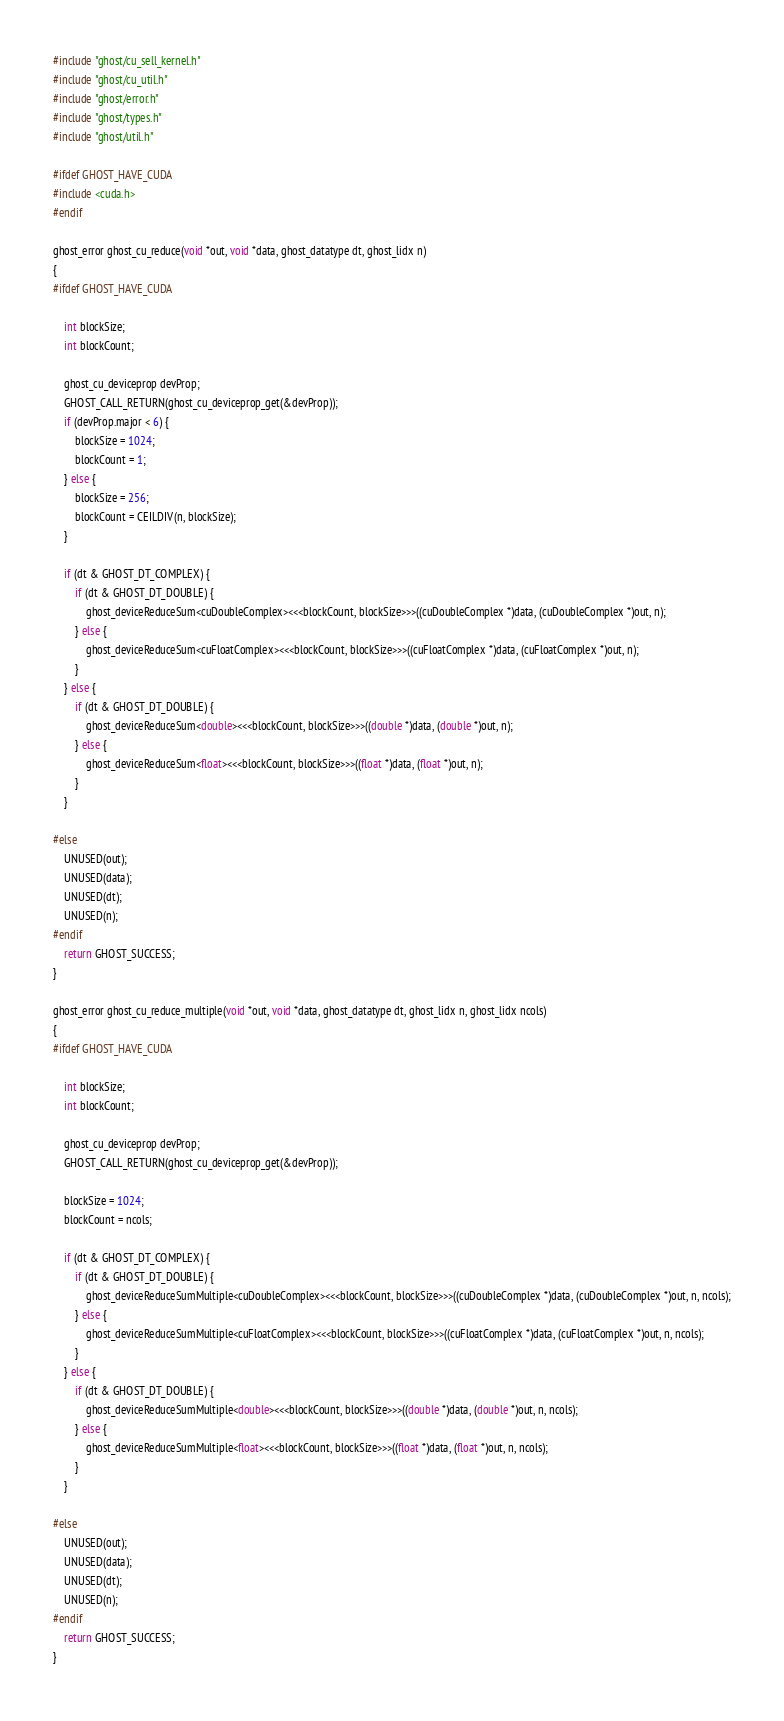Convert code to text. <code><loc_0><loc_0><loc_500><loc_500><_Cuda_>#include "ghost/cu_sell_kernel.h"
#include "ghost/cu_util.h"
#include "ghost/error.h"
#include "ghost/types.h"
#include "ghost/util.h"

#ifdef GHOST_HAVE_CUDA
#include <cuda.h>
#endif

ghost_error ghost_cu_reduce(void *out, void *data, ghost_datatype dt, ghost_lidx n)
{
#ifdef GHOST_HAVE_CUDA

    int blockSize;
    int blockCount;

    ghost_cu_deviceprop devProp;
    GHOST_CALL_RETURN(ghost_cu_deviceprop_get(&devProp));
    if (devProp.major < 6) {
        blockSize = 1024;
        blockCount = 1;
    } else {
        blockSize = 256;
        blockCount = CEILDIV(n, blockSize);
    }

    if (dt & GHOST_DT_COMPLEX) {
        if (dt & GHOST_DT_DOUBLE) {
            ghost_deviceReduceSum<cuDoubleComplex><<<blockCount, blockSize>>>((cuDoubleComplex *)data, (cuDoubleComplex *)out, n);
        } else {
            ghost_deviceReduceSum<cuFloatComplex><<<blockCount, blockSize>>>((cuFloatComplex *)data, (cuFloatComplex *)out, n);
        }
    } else {
        if (dt & GHOST_DT_DOUBLE) {
            ghost_deviceReduceSum<double><<<blockCount, blockSize>>>((double *)data, (double *)out, n);
        } else {
            ghost_deviceReduceSum<float><<<blockCount, blockSize>>>((float *)data, (float *)out, n);
        }
    }

#else
    UNUSED(out);
    UNUSED(data);
    UNUSED(dt);
    UNUSED(n);
#endif
    return GHOST_SUCCESS;
}

ghost_error ghost_cu_reduce_multiple(void *out, void *data, ghost_datatype dt, ghost_lidx n, ghost_lidx ncols)
{
#ifdef GHOST_HAVE_CUDA

    int blockSize;
    int blockCount;

    ghost_cu_deviceprop devProp;
    GHOST_CALL_RETURN(ghost_cu_deviceprop_get(&devProp));

    blockSize = 1024;
    blockCount = ncols;

    if (dt & GHOST_DT_COMPLEX) {
        if (dt & GHOST_DT_DOUBLE) {
            ghost_deviceReduceSumMultiple<cuDoubleComplex><<<blockCount, blockSize>>>((cuDoubleComplex *)data, (cuDoubleComplex *)out, n, ncols);
        } else {
            ghost_deviceReduceSumMultiple<cuFloatComplex><<<blockCount, blockSize>>>((cuFloatComplex *)data, (cuFloatComplex *)out, n, ncols);
        }
    } else {
        if (dt & GHOST_DT_DOUBLE) {
            ghost_deviceReduceSumMultiple<double><<<blockCount, blockSize>>>((double *)data, (double *)out, n, ncols);
        } else {
            ghost_deviceReduceSumMultiple<float><<<blockCount, blockSize>>>((float *)data, (float *)out, n, ncols);
        }
    }

#else
    UNUSED(out);
    UNUSED(data);
    UNUSED(dt);
    UNUSED(n);
#endif
    return GHOST_SUCCESS;
}
</code> 